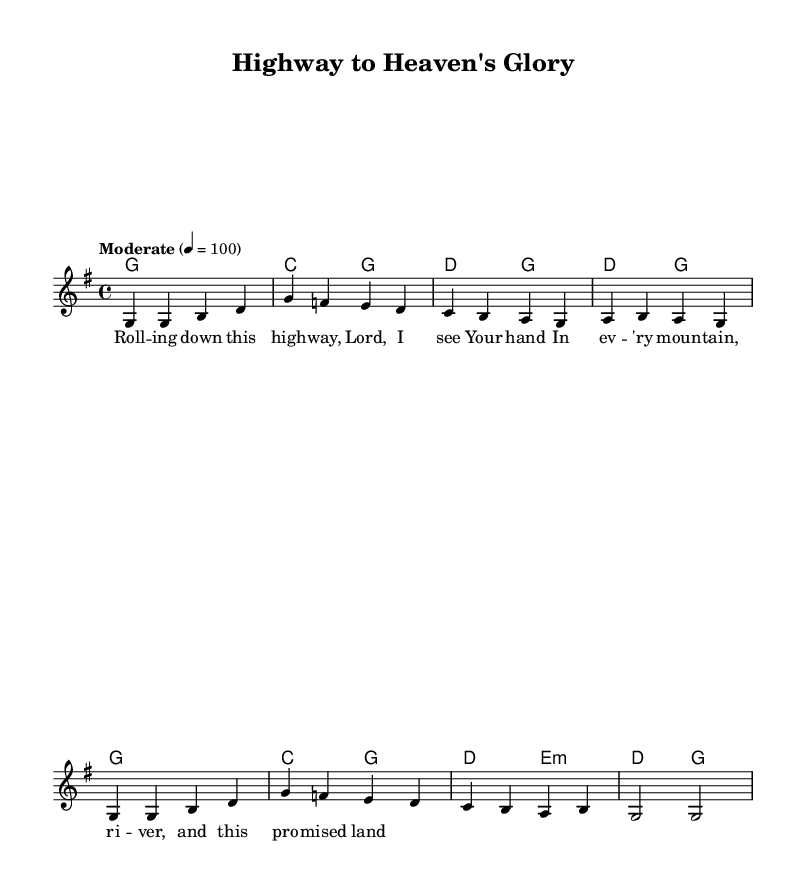What is the key signature of this music? The key signature is G major, which has one sharp (F♯).
Answer: G major What is the time signature of this music? The time signature is 4/4, indicating four beats per measure.
Answer: 4/4 What is the tempo marking for this piece? The tempo marking is "Moderate," specified as 4 beats per minute.
Answer: Moderate How many measures are there in the melody section? The melody section consists of eight measures, as counted by the number of measure lines.
Answer: Eight What is the last chord played before the repeat of the melody? The last chord before the repeat of the melody is D major.
Answer: D major What thematic element is celebrated in the lyrics of this song? The lyrics celebrate the beauty of God's creation, reflecting on nature and a promised land.
Answer: Beauty of God's creation In which section is the lyric information written? The lyric information is written in the verse section of the score, referring to the vocal melody.
Answer: Verse section 